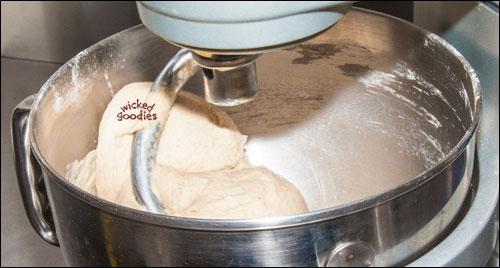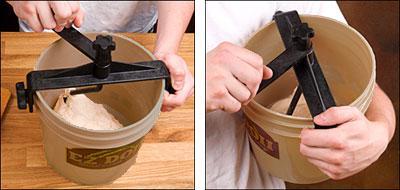The first image is the image on the left, the second image is the image on the right. Considering the images on both sides, is "in at least one image there a bucket full of dough that is being kneed." valid? Answer yes or no. Yes. The first image is the image on the left, the second image is the image on the right. For the images shown, is this caption "The mixer in the left image has a black power cord." true? Answer yes or no. No. 